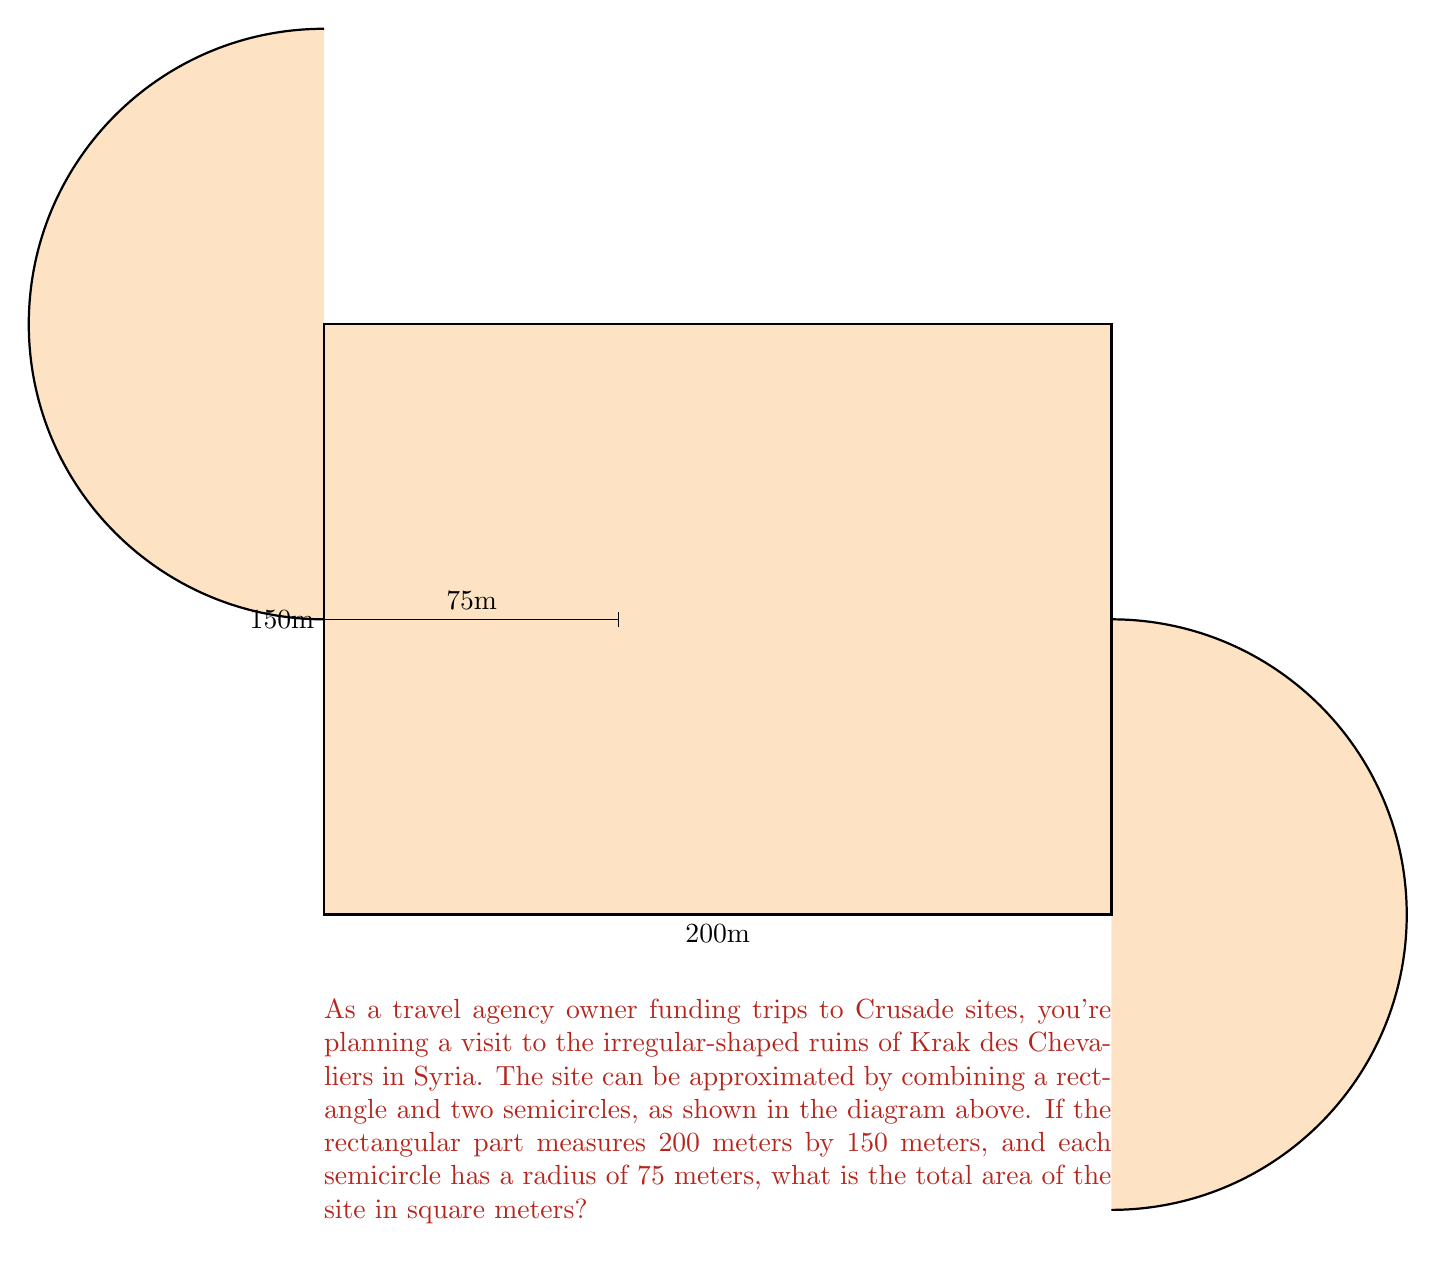Help me with this question. To solve this problem, we need to calculate the areas of the rectangle and the two semicircles separately, then sum them up:

1. Area of the rectangle:
   $A_r = l \times w = 200 \text{ m} \times 150 \text{ m} = 30,000 \text{ m}^2$

2. Area of one semicircle:
   $A_s = \frac{1}{2} \times \pi r^2 = \frac{1}{2} \times \pi \times (75 \text{ m})^2 = \frac{11,250\pi}{2} \text{ m}^2$

3. Total area of two semicircles:
   $A_{2s} = 2 \times \frac{11,250\pi}{2} \text{ m}^2 = 11,250\pi \text{ m}^2$

4. Total area of the site:
   $$\begin{align}
   A_{total} &= A_r + A_{2s} \\
   &= 30,000 \text{ m}^2 + 11,250\pi \text{ m}^2 \\
   &= 30,000 + 35,342.92 \text{ m}^2 \text{ (rounded to 2 decimal places)} \\
   &= 65,342.92 \text{ m}^2
   \end{align}$$

Therefore, the total area of the Krak des Chevaliers site is approximately 65,342.92 square meters.
Answer: 65,342.92 m² 